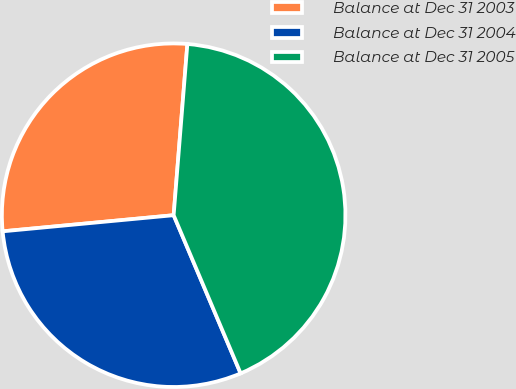Convert chart to OTSL. <chart><loc_0><loc_0><loc_500><loc_500><pie_chart><fcel>Balance at Dec 31 2003<fcel>Balance at Dec 31 2004<fcel>Balance at Dec 31 2005<nl><fcel>27.77%<fcel>29.88%<fcel>42.35%<nl></chart> 